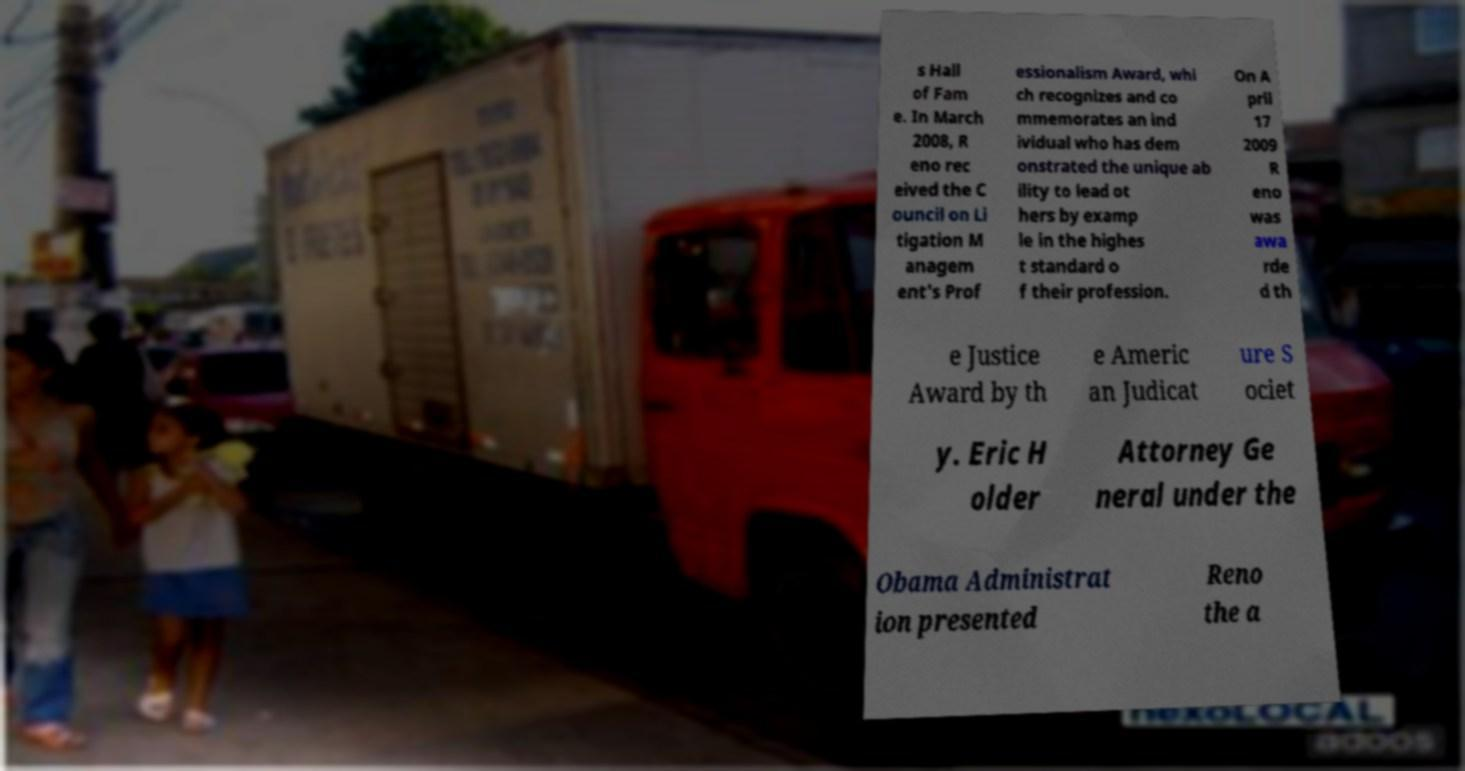Could you assist in decoding the text presented in this image and type it out clearly? s Hall of Fam e. In March 2008, R eno rec eived the C ouncil on Li tigation M anagem ent's Prof essionalism Award, whi ch recognizes and co mmemorates an ind ividual who has dem onstrated the unique ab ility to lead ot hers by examp le in the highes t standard o f their profession. On A pril 17 2009 R eno was awa rde d th e Justice Award by th e Americ an Judicat ure S ociet y. Eric H older Attorney Ge neral under the Obama Administrat ion presented Reno the a 